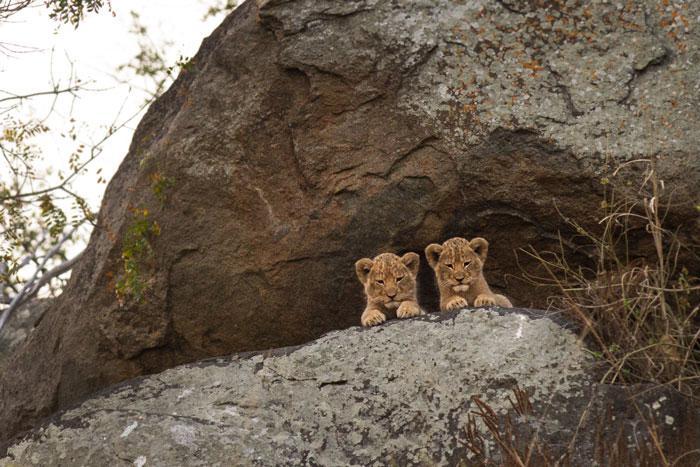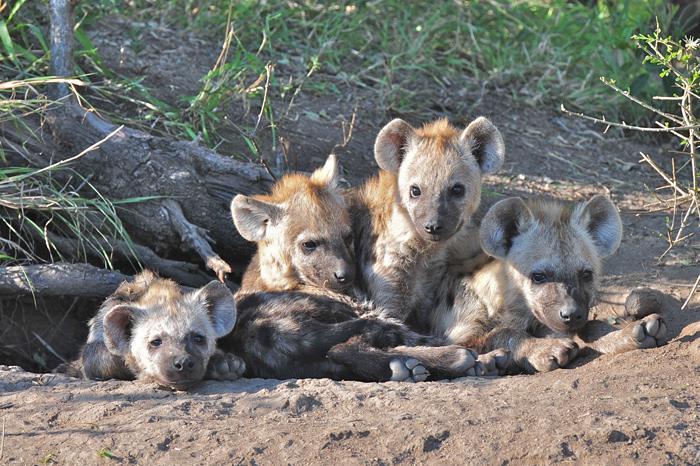The first image is the image on the left, the second image is the image on the right. For the images displayed, is the sentence "There are some lion cubs here." factually correct? Answer yes or no. Yes. 